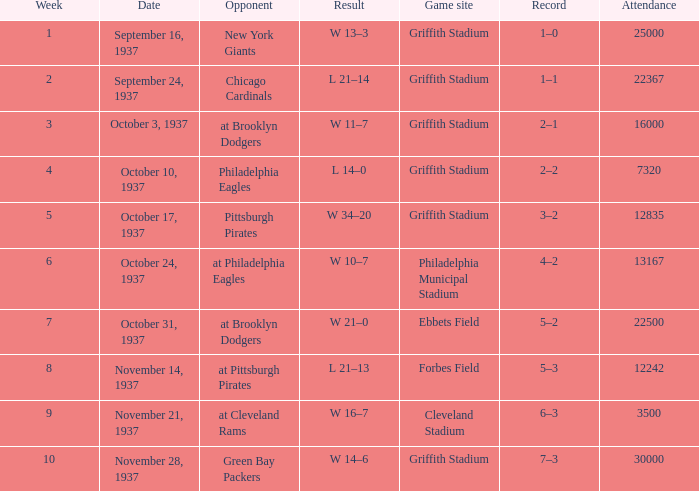I'm looking to parse the entire table for insights. Could you assist me with that? {'header': ['Week', 'Date', 'Opponent', 'Result', 'Game site', 'Record', 'Attendance'], 'rows': [['1', 'September 16, 1937', 'New York Giants', 'W 13–3', 'Griffith Stadium', '1–0', '25000'], ['2', 'September 24, 1937', 'Chicago Cardinals', 'L 21–14', 'Griffith Stadium', '1–1', '22367'], ['3', 'October 3, 1937', 'at Brooklyn Dodgers', 'W 11–7', 'Griffith Stadium', '2–1', '16000'], ['4', 'October 10, 1937', 'Philadelphia Eagles', 'L 14–0', 'Griffith Stadium', '2–2', '7320'], ['5', 'October 17, 1937', 'Pittsburgh Pirates', 'W 34–20', 'Griffith Stadium', '3–2', '12835'], ['6', 'October 24, 1937', 'at Philadelphia Eagles', 'W 10–7', 'Philadelphia Municipal Stadium', '4–2', '13167'], ['7', 'October 31, 1937', 'at Brooklyn Dodgers', 'W 21–0', 'Ebbets Field', '5–2', '22500'], ['8', 'November 14, 1937', 'at Pittsburgh Pirates', 'L 21–13', 'Forbes Field', '5–3', '12242'], ['9', 'November 21, 1937', 'at Cleveland Rams', 'W 16–7', 'Cleveland Stadium', '6–3', '3500'], ['10', 'November 28, 1937', 'Green Bay Packers', 'W 14–6', 'Griffith Stadium', '7–3', '30000']]} What are week 4 results?  L 14–0. 